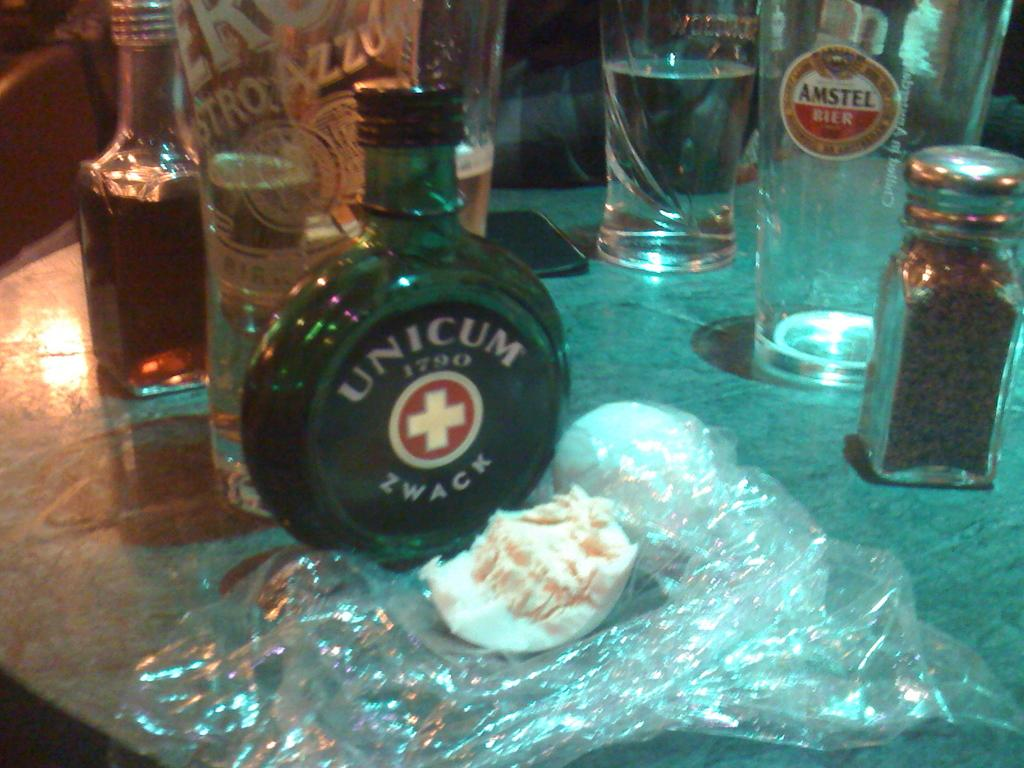<image>
Create a compact narrative representing the image presented. A round green glass bottle on a table with the words UNICUM 1790 ZWACK on the label. 